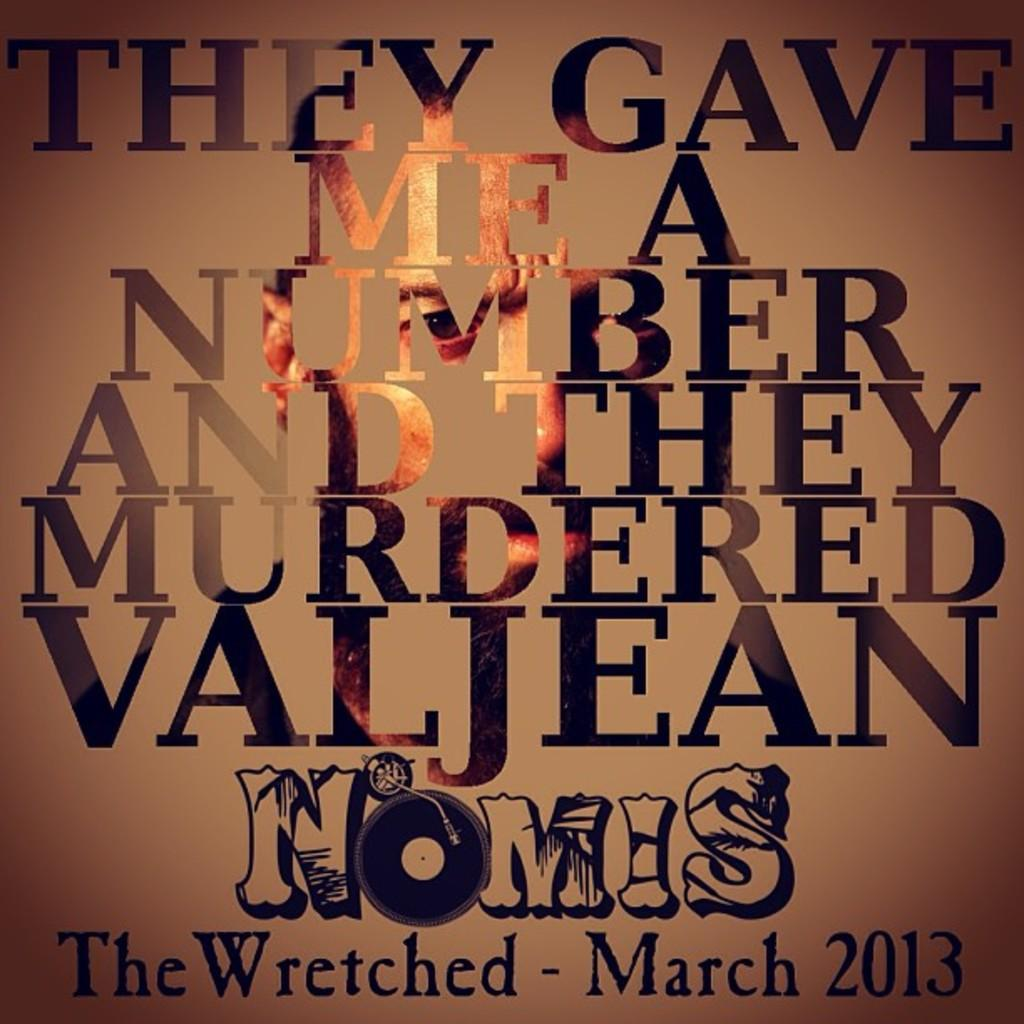What is the main object in the picture? There is a board in the picture. What is written or displayed on the board? There is text on the board. Can you describe any other elements in the picture? There is a person's face visible in the picture. What type of punishment is being depicted in the picture? There is no punishment being depicted in the picture; it features a board with text and a person's face. How many bananas are visible in the picture? There are no bananas present in the picture. 